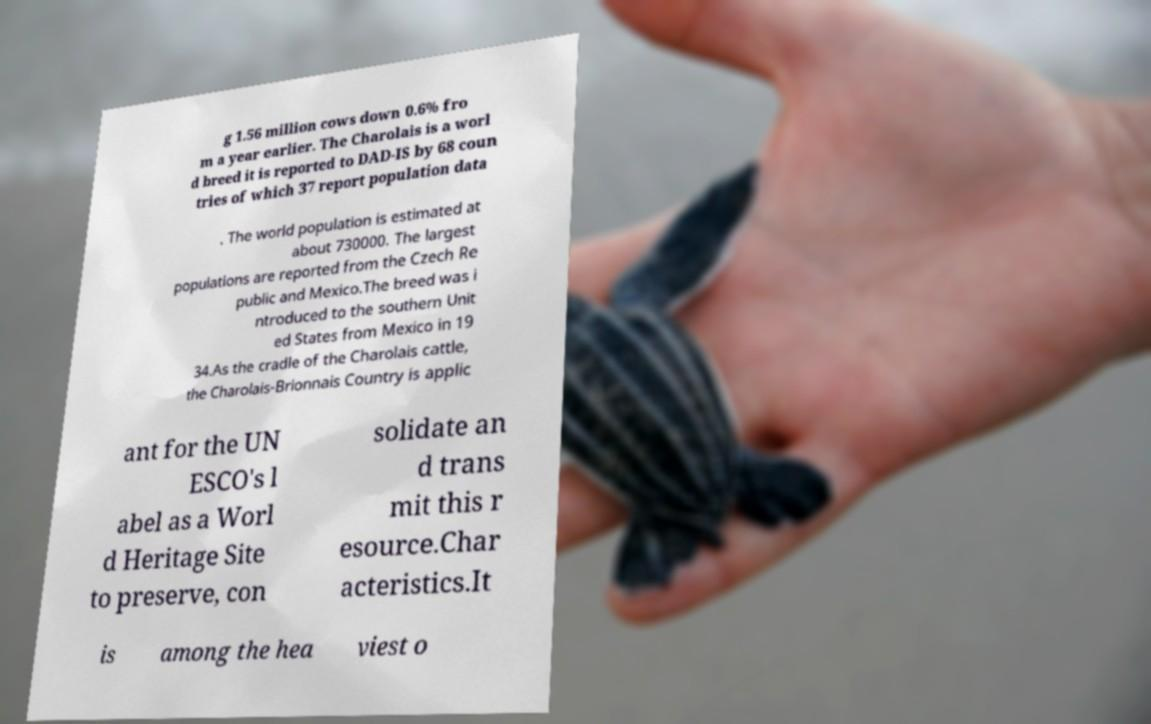Please identify and transcribe the text found in this image. g 1.56 million cows down 0.6% fro m a year earlier. The Charolais is a worl d breed it is reported to DAD-IS by 68 coun tries of which 37 report population data . The world population is estimated at about 730000. The largest populations are reported from the Czech Re public and Mexico.The breed was i ntroduced to the southern Unit ed States from Mexico in 19 34.As the cradle of the Charolais cattle, the Charolais-Brionnais Country is applic ant for the UN ESCO's l abel as a Worl d Heritage Site to preserve, con solidate an d trans mit this r esource.Char acteristics.It is among the hea viest o 